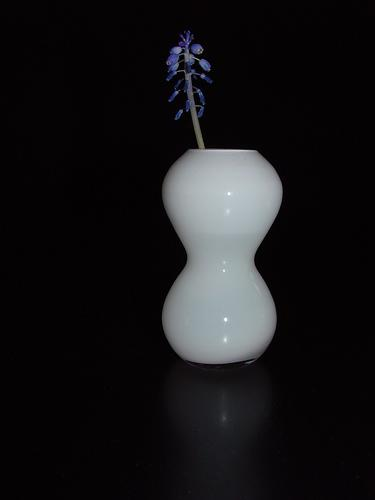Question: where is the lilac?
Choices:
A. In the vase.
B. Next to the tree.
C. In the flowerbed.
D. In a pot.
Answer with the letter. Answer: A Question: what is keeping the lilac upright?
Choices:
A. The lilac next to it.
B. The vase.
C. The flower pot.
D. The wall it's leaning on.
Answer with the letter. Answer: B Question: what color is the lilac?
Choices:
A. White.
B. Pink.
C. Yellow.
D. Purple.
Answer with the letter. Answer: D 